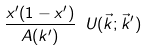<formula> <loc_0><loc_0><loc_500><loc_500>\frac { x ^ { \prime } ( 1 - x ^ { \prime } ) } { A ( k ^ { \prime } ) } \ U ( \vec { k } ; \vec { k } ^ { \prime } )</formula> 